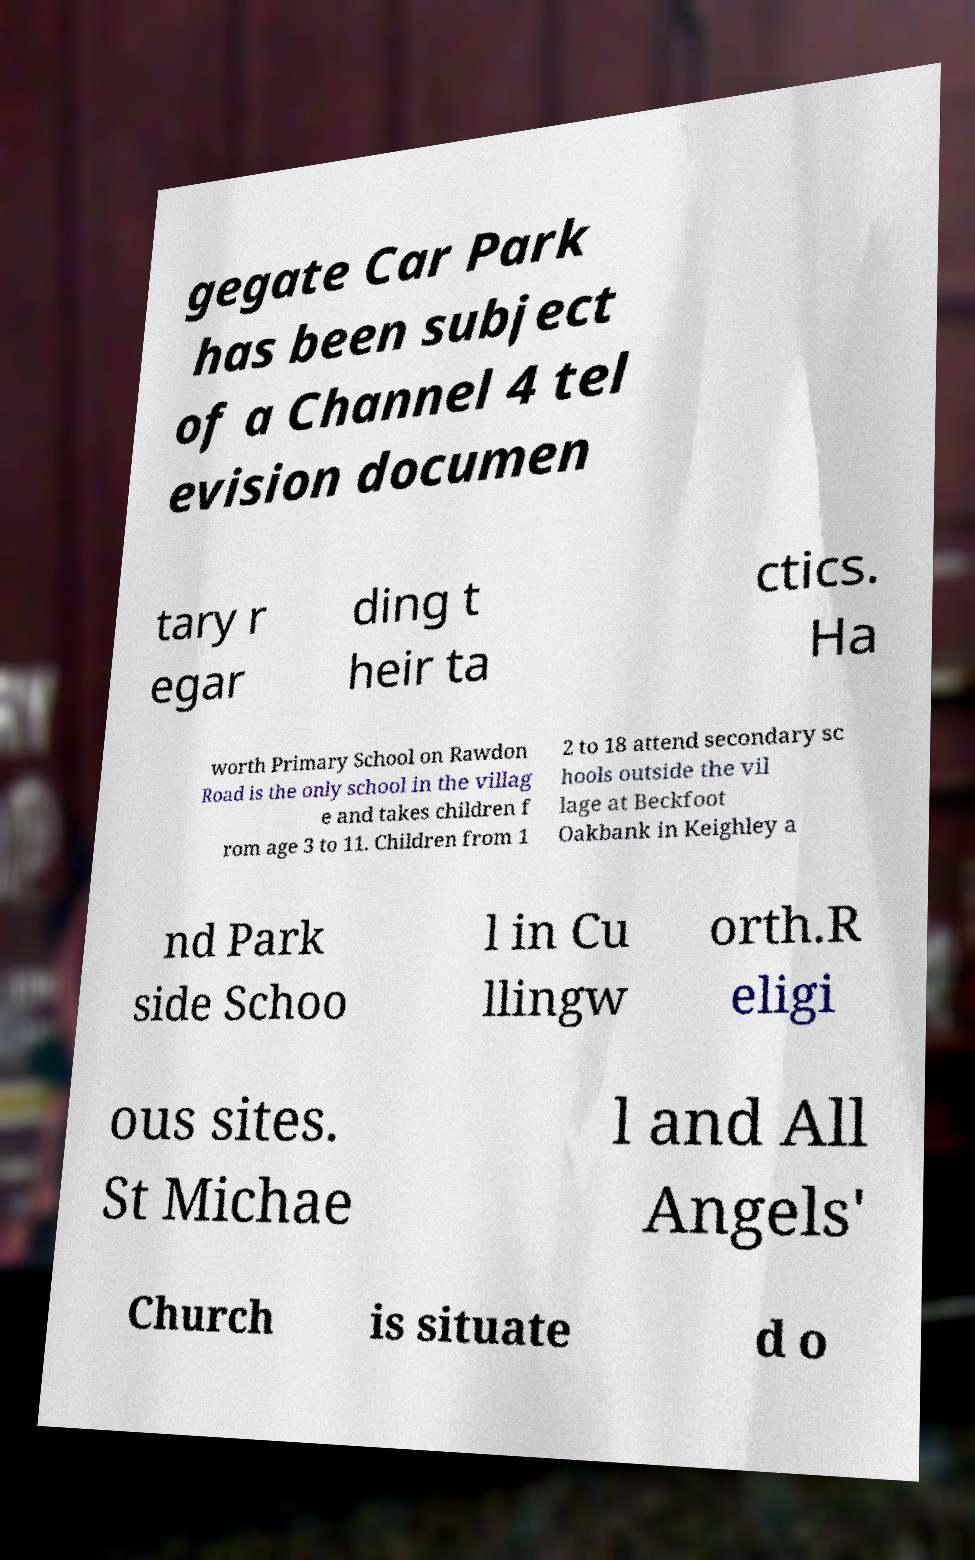For documentation purposes, I need the text within this image transcribed. Could you provide that? gegate Car Park has been subject of a Channel 4 tel evision documen tary r egar ding t heir ta ctics. Ha worth Primary School on Rawdon Road is the only school in the villag e and takes children f rom age 3 to 11. Children from 1 2 to 18 attend secondary sc hools outside the vil lage at Beckfoot Oakbank in Keighley a nd Park side Schoo l in Cu llingw orth.R eligi ous sites. St Michae l and All Angels' Church is situate d o 